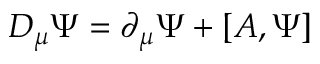Convert formula to latex. <formula><loc_0><loc_0><loc_500><loc_500>D _ { \mu } \Psi = \partial _ { \mu } \Psi + \left [ A , \Psi \right ]</formula> 